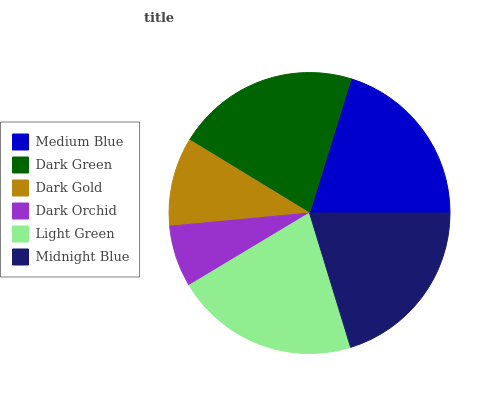Is Dark Orchid the minimum?
Answer yes or no. Yes. Is Light Green the maximum?
Answer yes or no. Yes. Is Dark Green the minimum?
Answer yes or no. No. Is Dark Green the maximum?
Answer yes or no. No. Is Dark Green greater than Medium Blue?
Answer yes or no. Yes. Is Medium Blue less than Dark Green?
Answer yes or no. Yes. Is Medium Blue greater than Dark Green?
Answer yes or no. No. Is Dark Green less than Medium Blue?
Answer yes or no. No. Is Midnight Blue the high median?
Answer yes or no. Yes. Is Medium Blue the low median?
Answer yes or no. Yes. Is Dark Orchid the high median?
Answer yes or no. No. Is Dark Green the low median?
Answer yes or no. No. 